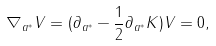<formula> <loc_0><loc_0><loc_500><loc_500>\nabla _ { a ^ { * } } V = ( \partial _ { a ^ { * } } - \frac { 1 } { 2 } \partial _ { a ^ { * } } K ) V = 0 ,</formula> 